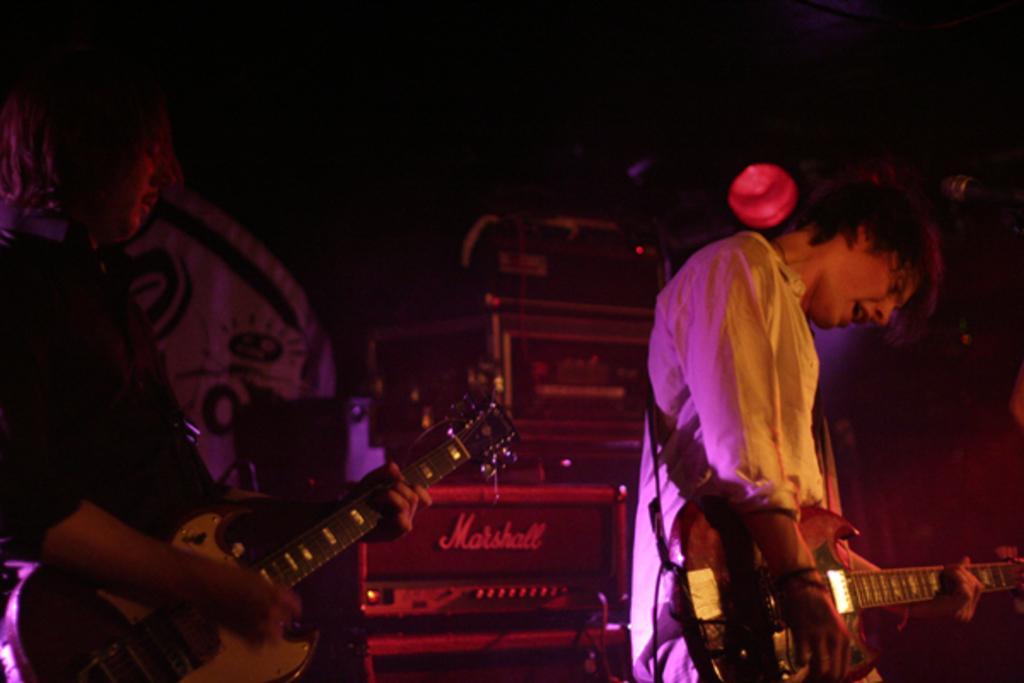In one or two sentences, can you explain what this image depicts? In this image, There are 2 peoples are playing a musical instrument. At the back side, we can see some boxes. And here, we can see a curtain there. Here there is a light. 